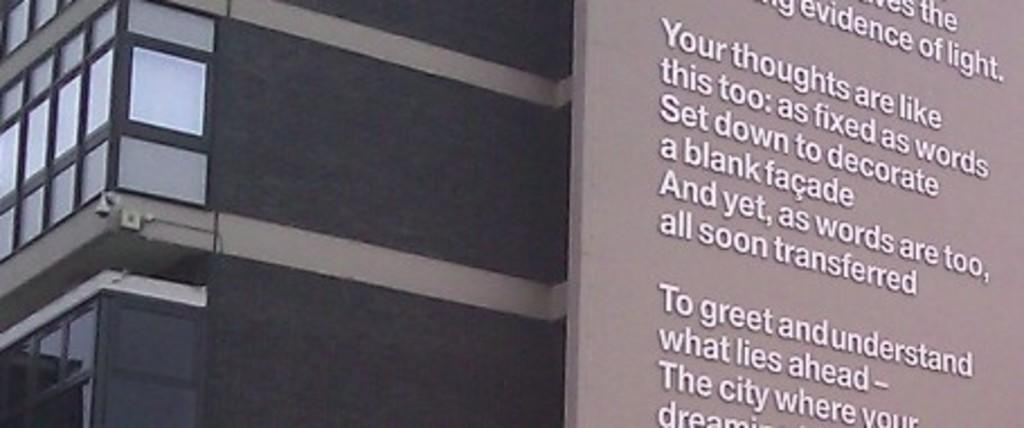What can be seen on the right side of the image? There are texts on a surface on the right side of the image. What is visible on the left side of the image? There are windows of a building on the left side of the image. What type of drink is being served in the image? There is no drink present in the image. What is the temperature of the building in the image? The temperature of the building cannot be determined from the image, as it only shows windows and texts. 